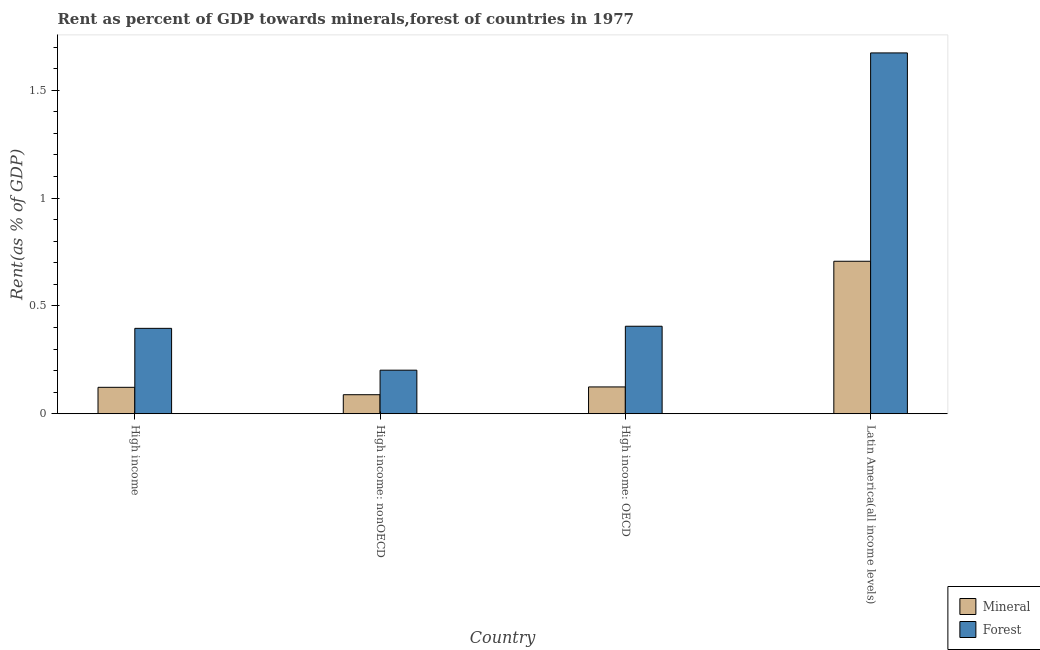How many different coloured bars are there?
Your response must be concise. 2. Are the number of bars on each tick of the X-axis equal?
Your answer should be very brief. Yes. How many bars are there on the 2nd tick from the left?
Provide a short and direct response. 2. How many bars are there on the 4th tick from the right?
Offer a terse response. 2. What is the label of the 4th group of bars from the left?
Keep it short and to the point. Latin America(all income levels). What is the forest rent in High income?
Ensure brevity in your answer.  0.4. Across all countries, what is the maximum forest rent?
Ensure brevity in your answer.  1.67. Across all countries, what is the minimum forest rent?
Offer a very short reply. 0.2. In which country was the forest rent maximum?
Ensure brevity in your answer.  Latin America(all income levels). In which country was the forest rent minimum?
Your answer should be compact. High income: nonOECD. What is the total forest rent in the graph?
Offer a terse response. 2.68. What is the difference between the forest rent in High income and that in High income: OECD?
Your answer should be compact. -0.01. What is the difference between the forest rent in High income: OECD and the mineral rent in High income: nonOECD?
Make the answer very short. 0.32. What is the average forest rent per country?
Make the answer very short. 0.67. What is the difference between the mineral rent and forest rent in High income: OECD?
Ensure brevity in your answer.  -0.28. What is the ratio of the forest rent in High income to that in High income: nonOECD?
Your answer should be compact. 1.96. Is the difference between the forest rent in High income: OECD and Latin America(all income levels) greater than the difference between the mineral rent in High income: OECD and Latin America(all income levels)?
Make the answer very short. No. What is the difference between the highest and the second highest mineral rent?
Provide a short and direct response. 0.58. What is the difference between the highest and the lowest mineral rent?
Keep it short and to the point. 0.62. In how many countries, is the forest rent greater than the average forest rent taken over all countries?
Give a very brief answer. 1. What does the 2nd bar from the left in High income: OECD represents?
Keep it short and to the point. Forest. What does the 1st bar from the right in Latin America(all income levels) represents?
Provide a succinct answer. Forest. Are all the bars in the graph horizontal?
Make the answer very short. No. Does the graph contain grids?
Make the answer very short. No. What is the title of the graph?
Your answer should be compact. Rent as percent of GDP towards minerals,forest of countries in 1977. Does "Banks" appear as one of the legend labels in the graph?
Ensure brevity in your answer.  No. What is the label or title of the X-axis?
Your answer should be very brief. Country. What is the label or title of the Y-axis?
Give a very brief answer. Rent(as % of GDP). What is the Rent(as % of GDP) of Mineral in High income?
Ensure brevity in your answer.  0.12. What is the Rent(as % of GDP) of Forest in High income?
Provide a short and direct response. 0.4. What is the Rent(as % of GDP) in Mineral in High income: nonOECD?
Your answer should be very brief. 0.09. What is the Rent(as % of GDP) of Forest in High income: nonOECD?
Your answer should be compact. 0.2. What is the Rent(as % of GDP) of Mineral in High income: OECD?
Your answer should be very brief. 0.12. What is the Rent(as % of GDP) of Forest in High income: OECD?
Offer a very short reply. 0.41. What is the Rent(as % of GDP) of Mineral in Latin America(all income levels)?
Your answer should be very brief. 0.71. What is the Rent(as % of GDP) in Forest in Latin America(all income levels)?
Provide a short and direct response. 1.67. Across all countries, what is the maximum Rent(as % of GDP) in Mineral?
Give a very brief answer. 0.71. Across all countries, what is the maximum Rent(as % of GDP) in Forest?
Your answer should be compact. 1.67. Across all countries, what is the minimum Rent(as % of GDP) in Mineral?
Give a very brief answer. 0.09. Across all countries, what is the minimum Rent(as % of GDP) in Forest?
Keep it short and to the point. 0.2. What is the total Rent(as % of GDP) of Mineral in the graph?
Provide a succinct answer. 1.04. What is the total Rent(as % of GDP) of Forest in the graph?
Your answer should be very brief. 2.68. What is the difference between the Rent(as % of GDP) in Mineral in High income and that in High income: nonOECD?
Give a very brief answer. 0.03. What is the difference between the Rent(as % of GDP) of Forest in High income and that in High income: nonOECD?
Offer a very short reply. 0.19. What is the difference between the Rent(as % of GDP) in Mineral in High income and that in High income: OECD?
Make the answer very short. -0. What is the difference between the Rent(as % of GDP) in Forest in High income and that in High income: OECD?
Ensure brevity in your answer.  -0.01. What is the difference between the Rent(as % of GDP) in Mineral in High income and that in Latin America(all income levels)?
Provide a succinct answer. -0.58. What is the difference between the Rent(as % of GDP) in Forest in High income and that in Latin America(all income levels)?
Your response must be concise. -1.28. What is the difference between the Rent(as % of GDP) of Mineral in High income: nonOECD and that in High income: OECD?
Make the answer very short. -0.04. What is the difference between the Rent(as % of GDP) in Forest in High income: nonOECD and that in High income: OECD?
Your answer should be very brief. -0.2. What is the difference between the Rent(as % of GDP) of Mineral in High income: nonOECD and that in Latin America(all income levels)?
Provide a succinct answer. -0.62. What is the difference between the Rent(as % of GDP) in Forest in High income: nonOECD and that in Latin America(all income levels)?
Ensure brevity in your answer.  -1.47. What is the difference between the Rent(as % of GDP) in Mineral in High income: OECD and that in Latin America(all income levels)?
Your response must be concise. -0.58. What is the difference between the Rent(as % of GDP) of Forest in High income: OECD and that in Latin America(all income levels)?
Your answer should be very brief. -1.27. What is the difference between the Rent(as % of GDP) in Mineral in High income and the Rent(as % of GDP) in Forest in High income: nonOECD?
Provide a succinct answer. -0.08. What is the difference between the Rent(as % of GDP) of Mineral in High income and the Rent(as % of GDP) of Forest in High income: OECD?
Your answer should be very brief. -0.28. What is the difference between the Rent(as % of GDP) in Mineral in High income and the Rent(as % of GDP) in Forest in Latin America(all income levels)?
Keep it short and to the point. -1.55. What is the difference between the Rent(as % of GDP) of Mineral in High income: nonOECD and the Rent(as % of GDP) of Forest in High income: OECD?
Provide a succinct answer. -0.32. What is the difference between the Rent(as % of GDP) of Mineral in High income: nonOECD and the Rent(as % of GDP) of Forest in Latin America(all income levels)?
Offer a terse response. -1.58. What is the difference between the Rent(as % of GDP) of Mineral in High income: OECD and the Rent(as % of GDP) of Forest in Latin America(all income levels)?
Your answer should be compact. -1.55. What is the average Rent(as % of GDP) in Mineral per country?
Provide a succinct answer. 0.26. What is the average Rent(as % of GDP) of Forest per country?
Your answer should be compact. 0.67. What is the difference between the Rent(as % of GDP) in Mineral and Rent(as % of GDP) in Forest in High income?
Your answer should be compact. -0.27. What is the difference between the Rent(as % of GDP) in Mineral and Rent(as % of GDP) in Forest in High income: nonOECD?
Provide a succinct answer. -0.11. What is the difference between the Rent(as % of GDP) in Mineral and Rent(as % of GDP) in Forest in High income: OECD?
Offer a very short reply. -0.28. What is the difference between the Rent(as % of GDP) in Mineral and Rent(as % of GDP) in Forest in Latin America(all income levels)?
Keep it short and to the point. -0.97. What is the ratio of the Rent(as % of GDP) of Mineral in High income to that in High income: nonOECD?
Give a very brief answer. 1.39. What is the ratio of the Rent(as % of GDP) in Forest in High income to that in High income: nonOECD?
Provide a short and direct response. 1.96. What is the ratio of the Rent(as % of GDP) of Mineral in High income to that in High income: OECD?
Give a very brief answer. 0.99. What is the ratio of the Rent(as % of GDP) in Forest in High income to that in High income: OECD?
Provide a short and direct response. 0.98. What is the ratio of the Rent(as % of GDP) of Mineral in High income to that in Latin America(all income levels)?
Make the answer very short. 0.17. What is the ratio of the Rent(as % of GDP) in Forest in High income to that in Latin America(all income levels)?
Provide a succinct answer. 0.24. What is the ratio of the Rent(as % of GDP) in Mineral in High income: nonOECD to that in High income: OECD?
Your response must be concise. 0.71. What is the ratio of the Rent(as % of GDP) of Forest in High income: nonOECD to that in High income: OECD?
Offer a very short reply. 0.5. What is the ratio of the Rent(as % of GDP) of Mineral in High income: nonOECD to that in Latin America(all income levels)?
Your response must be concise. 0.12. What is the ratio of the Rent(as % of GDP) of Forest in High income: nonOECD to that in Latin America(all income levels)?
Your response must be concise. 0.12. What is the ratio of the Rent(as % of GDP) of Mineral in High income: OECD to that in Latin America(all income levels)?
Offer a very short reply. 0.18. What is the ratio of the Rent(as % of GDP) in Forest in High income: OECD to that in Latin America(all income levels)?
Your response must be concise. 0.24. What is the difference between the highest and the second highest Rent(as % of GDP) in Mineral?
Provide a short and direct response. 0.58. What is the difference between the highest and the second highest Rent(as % of GDP) in Forest?
Offer a very short reply. 1.27. What is the difference between the highest and the lowest Rent(as % of GDP) in Mineral?
Offer a terse response. 0.62. What is the difference between the highest and the lowest Rent(as % of GDP) of Forest?
Keep it short and to the point. 1.47. 